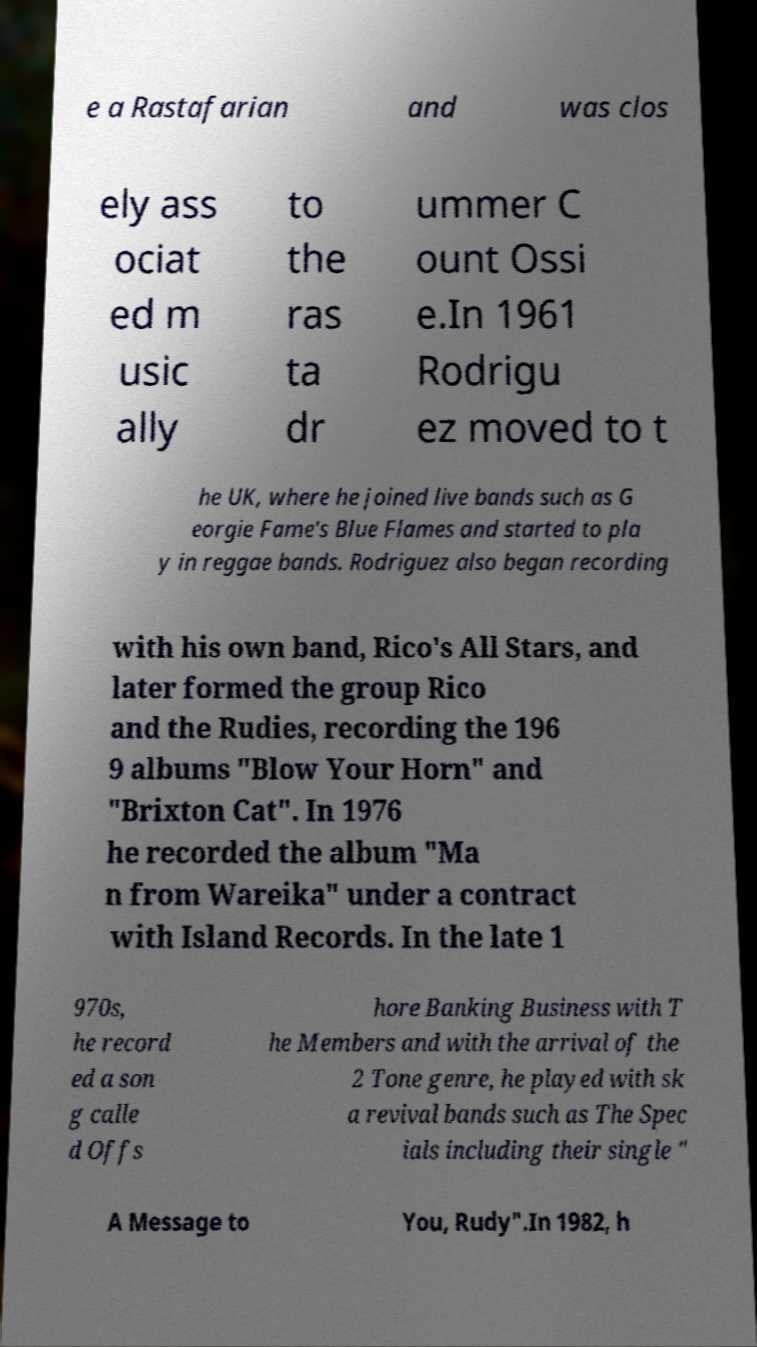What messages or text are displayed in this image? I need them in a readable, typed format. e a Rastafarian and was clos ely ass ociat ed m usic ally to the ras ta dr ummer C ount Ossi e.In 1961 Rodrigu ez moved to t he UK, where he joined live bands such as G eorgie Fame's Blue Flames and started to pla y in reggae bands. Rodriguez also began recording with his own band, Rico's All Stars, and later formed the group Rico and the Rudies, recording the 196 9 albums "Blow Your Horn" and "Brixton Cat". In 1976 he recorded the album "Ma n from Wareika" under a contract with Island Records. In the late 1 970s, he record ed a son g calle d Offs hore Banking Business with T he Members and with the arrival of the 2 Tone genre, he played with sk a revival bands such as The Spec ials including their single " A Message to You, Rudy".In 1982, h 